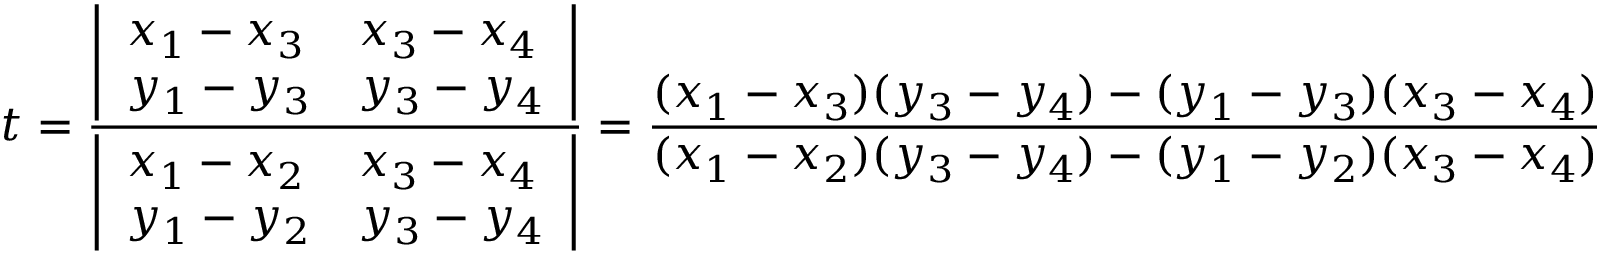<formula> <loc_0><loc_0><loc_500><loc_500>t = { \frac { \left | \begin{array} { l l } { x _ { 1 } - x _ { 3 } } & { x _ { 3 } - x _ { 4 } } \\ { y _ { 1 } - y _ { 3 } } & { y _ { 3 } - y _ { 4 } } \end{array} \right | } { \left | \begin{array} { l l } { x _ { 1 } - x _ { 2 } } & { x _ { 3 } - x _ { 4 } } \\ { y _ { 1 } - y _ { 2 } } & { y _ { 3 } - y _ { 4 } } \end{array} \right | } } = { \frac { ( x _ { 1 } - x _ { 3 } ) ( y _ { 3 } - y _ { 4 } ) - ( y _ { 1 } - y _ { 3 } ) ( x _ { 3 } - x _ { 4 } ) } { ( x _ { 1 } - x _ { 2 } ) ( y _ { 3 } - y _ { 4 } ) - ( y _ { 1 } - y _ { 2 } ) ( x _ { 3 } - x _ { 4 } ) } }</formula> 